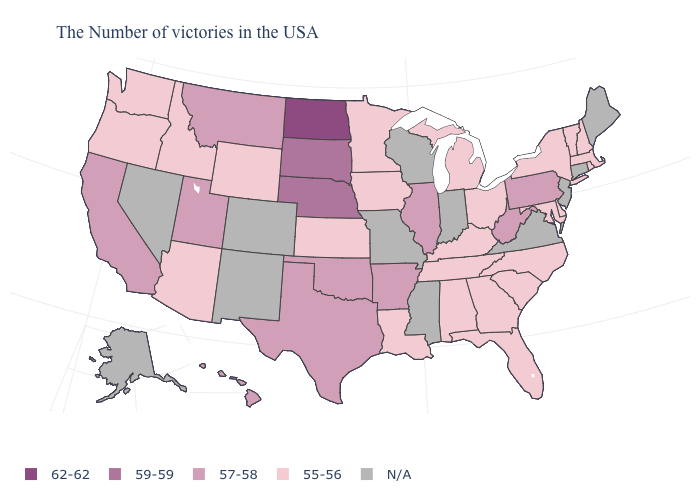What is the value of New York?
Give a very brief answer. 55-56. What is the value of Washington?
Answer briefly. 55-56. Which states have the lowest value in the USA?
Quick response, please. Massachusetts, Rhode Island, New Hampshire, Vermont, New York, Delaware, Maryland, North Carolina, South Carolina, Ohio, Florida, Georgia, Michigan, Kentucky, Alabama, Tennessee, Louisiana, Minnesota, Iowa, Kansas, Wyoming, Arizona, Idaho, Washington, Oregon. What is the value of Missouri?
Keep it brief. N/A. What is the lowest value in the Northeast?
Keep it brief. 55-56. What is the value of South Carolina?
Keep it brief. 55-56. What is the value of North Carolina?
Concise answer only. 55-56. What is the lowest value in states that border Missouri?
Quick response, please. 55-56. Does North Dakota have the highest value in the MidWest?
Quick response, please. Yes. Name the states that have a value in the range 62-62?
Short answer required. North Dakota. How many symbols are there in the legend?
Write a very short answer. 5. Which states have the lowest value in the USA?
Short answer required. Massachusetts, Rhode Island, New Hampshire, Vermont, New York, Delaware, Maryland, North Carolina, South Carolina, Ohio, Florida, Georgia, Michigan, Kentucky, Alabama, Tennessee, Louisiana, Minnesota, Iowa, Kansas, Wyoming, Arizona, Idaho, Washington, Oregon. 